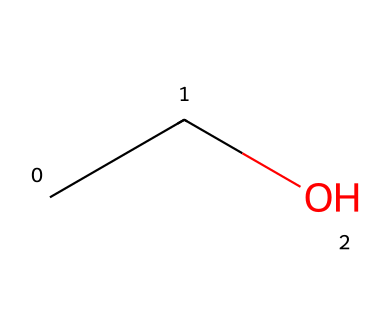What is the name of this chemical? This chemical is represented by the SMILES notation "CCO," which corresponds to ethanol. Ethanol is commonly known as ethyl alcohol and is a primary component of alcoholic beverages, including Irish whiskey.
Answer: ethanol How many carbon atoms are in this chemical? In the SMILES representation "CCO," there are two "C" atoms, which indicates that the molecule contains two carbon atoms. Each letter "C" represents a carbon atom.
Answer: two What type of alcohol is represented by this structure? The structure encoded by "CCO" is ethanol, which is classified as a primary alcohol because the hydroxyl (-OH) group is attached to a carbon atom bearing only one other carbon atom.
Answer: primary What is the molecular formula of this compound? Ethanol has the molecular formula C2H6O. This is derived from counting the carbon atoms (C2), the hydrogen atoms (H6), and the oxygen atom (O) present in the structure represented by "CCO."
Answer: C2H6O How many hydrogen atoms are present in this molecule? In the "CCO" representation of ethanol, there are a total of six hydrogen atoms. Each carbon forms bonds to enough hydrogen atoms to satisfy carbon’s tetravalency, resulting in two carbon atoms being fully saturated with hydrogen.
Answer: six Does this alcoholic compound have psychoactive effects? Yes, ethanol is a psychoactive substance; it affects the central nervous system, leading to both depressant effects and altered states of consciousness when consumed, which is typical for alcoholic beverages like Irish whiskey.
Answer: yes 